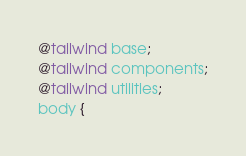Convert code to text. <code><loc_0><loc_0><loc_500><loc_500><_CSS_>@tailwind base;
@tailwind components;
@tailwind utilities;
body {</code> 